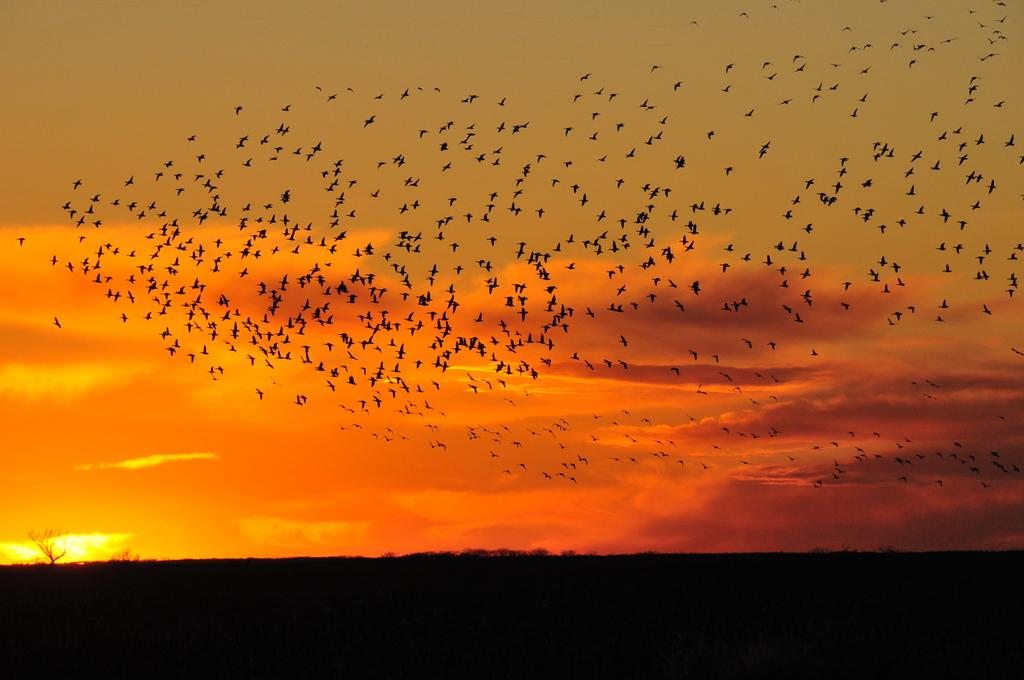What is happening in the sky in the image? There are many birds flying in the sky in the image. What color is the sky in the image? The sky is in an orange color. What color is the bottom part of the image? The bottom of the picture is black in color. What position does the grain hold in the image? There is no grain present in the image. What time of day does the image depict, considering the orange sky? The image does not provide enough information to determine the time of day, as the orange sky could be present during sunrise, sunset, or other conditions. 